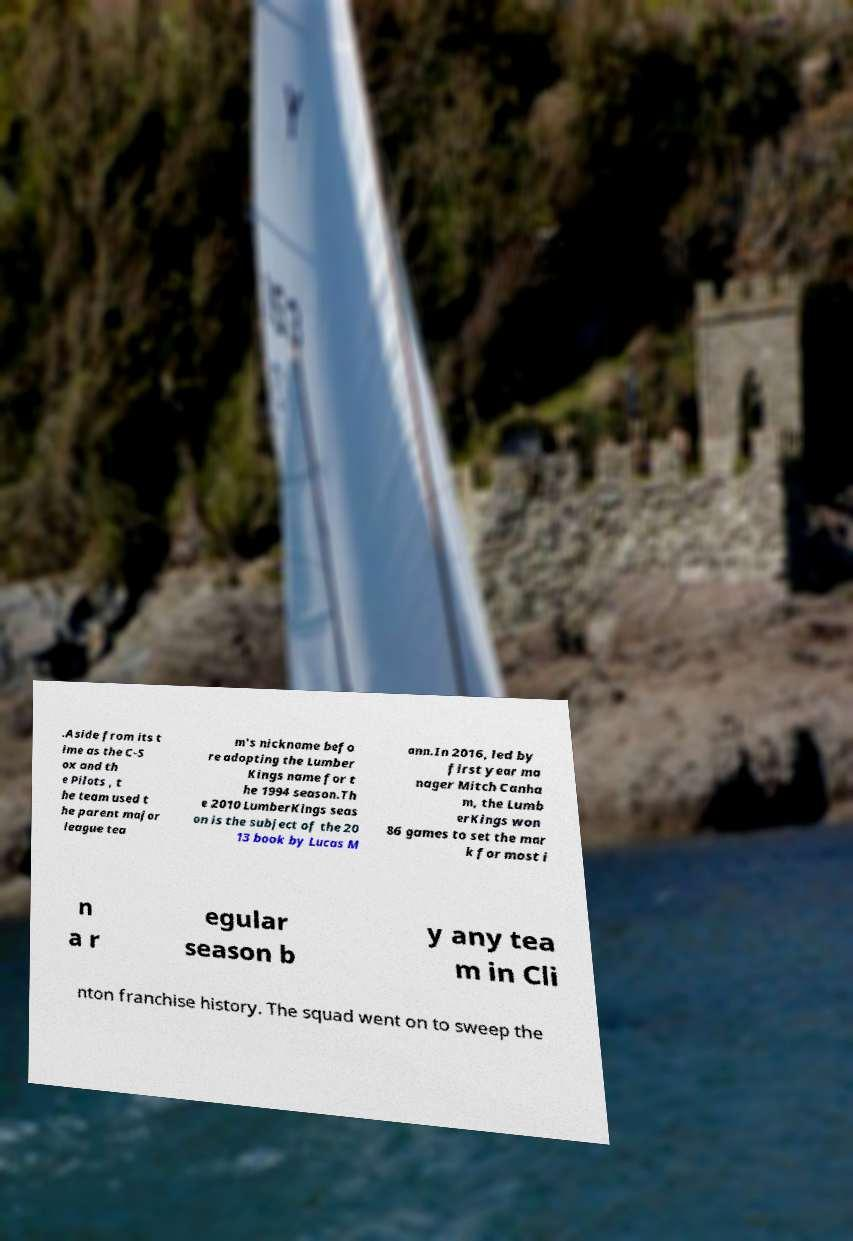I need the written content from this picture converted into text. Can you do that? .Aside from its t ime as the C-S ox and th e Pilots , t he team used t he parent major league tea m's nickname befo re adopting the Lumber Kings name for t he 1994 season.Th e 2010 LumberKings seas on is the subject of the 20 13 book by Lucas M ann.In 2016, led by first year ma nager Mitch Canha m, the Lumb erKings won 86 games to set the mar k for most i n a r egular season b y any tea m in Cli nton franchise history. The squad went on to sweep the 